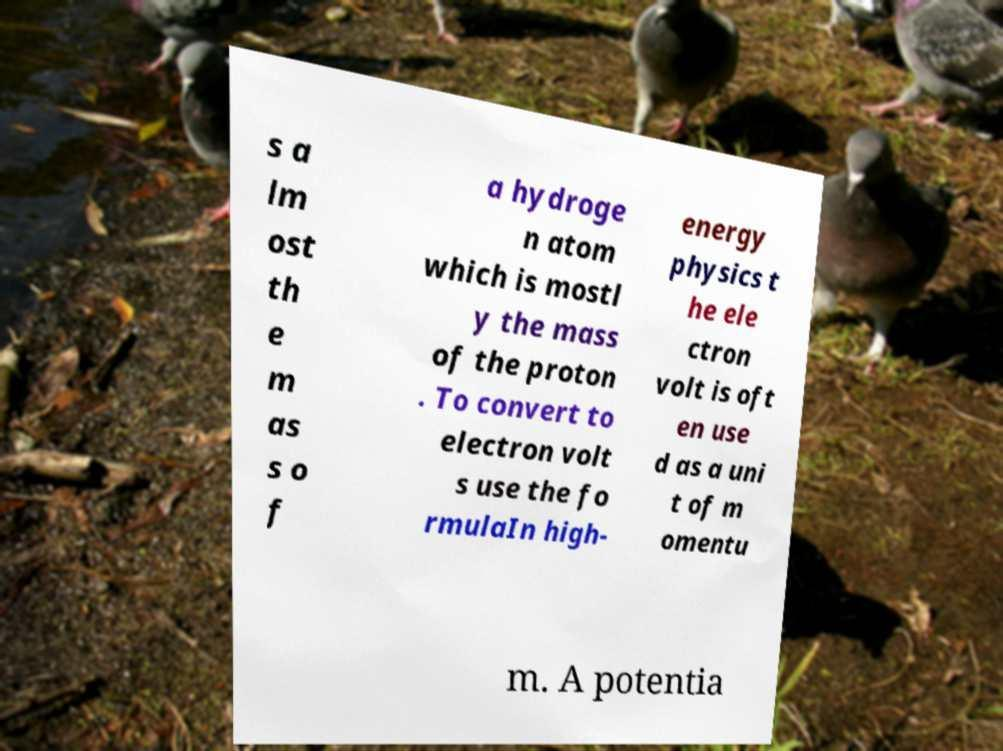Could you assist in decoding the text presented in this image and type it out clearly? s a lm ost th e m as s o f a hydroge n atom which is mostl y the mass of the proton . To convert to electron volt s use the fo rmulaIn high- energy physics t he ele ctron volt is oft en use d as a uni t of m omentu m. A potentia 